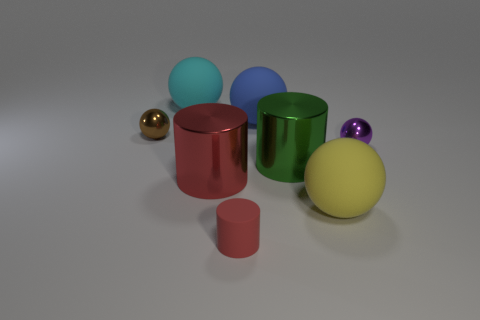What colors are the large cylinders in the image? The large cylinders present in the image flaunt a metallic finish, with one cylinder showcasing a rich green hue while the other boasts a vibrant red. 